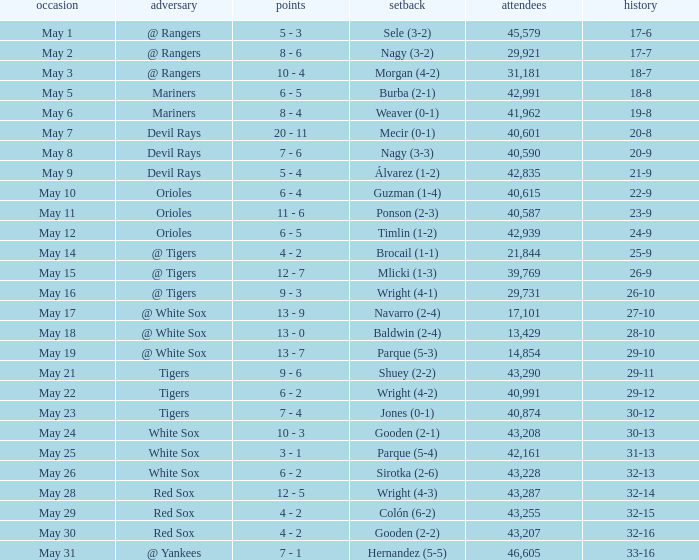What loss has 26-9 as a loss? Mlicki (1-3). 